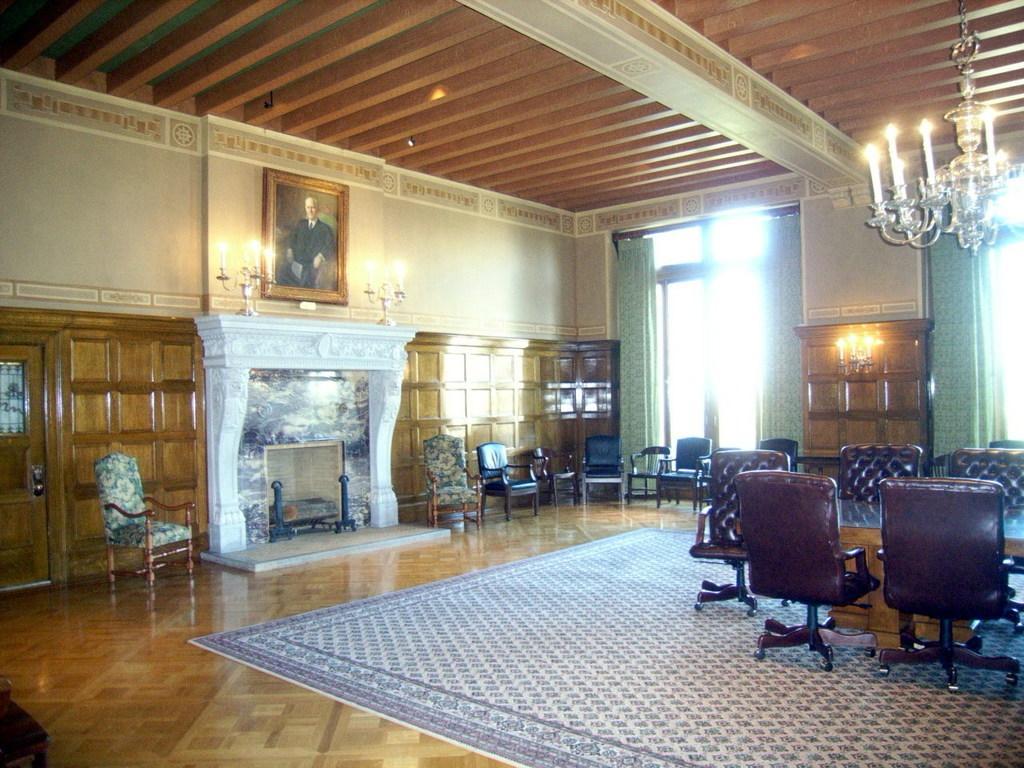Could you give a brief overview of what you see in this image? In a hall there are many chairs and a table and on the left side there is a fire pit and above that there are two candle holders with few candles and in the background there is a wall and there is a photo frame attached to the wall, on the right side there is a window and there are curtains in front of the window. 